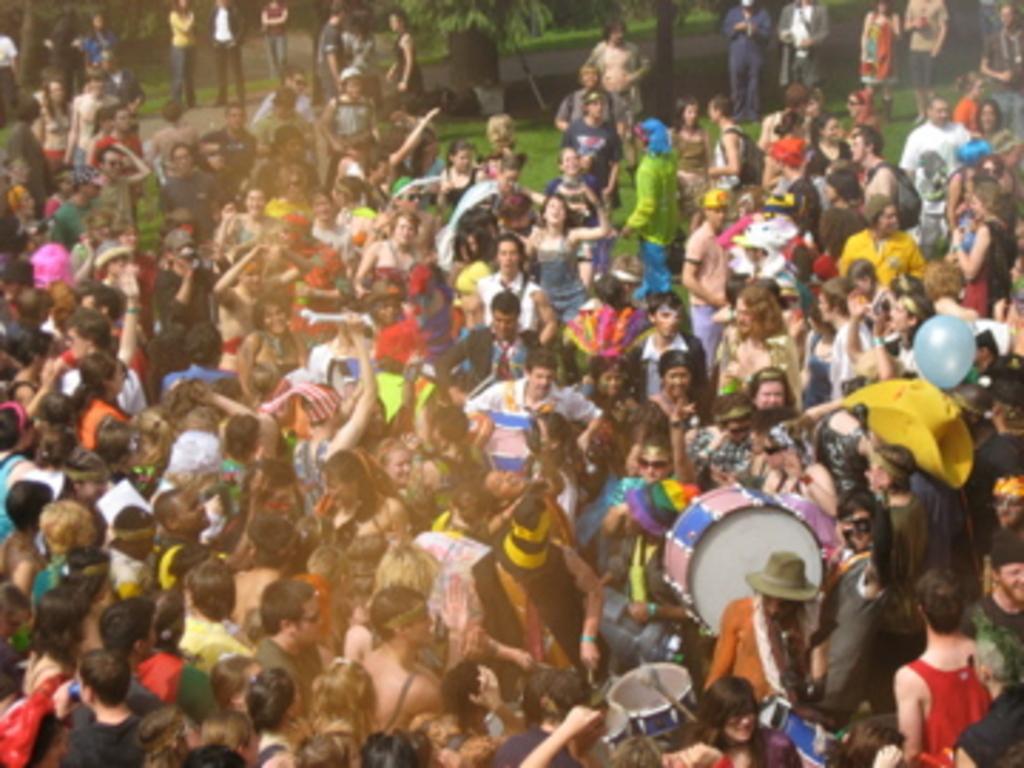Could you give a brief overview of what you see in this image? In front of the image there are a few people holding the drums and there are a few people standing. At the bottom of the image there is grass on the surface. In the background of the image there are trees. 